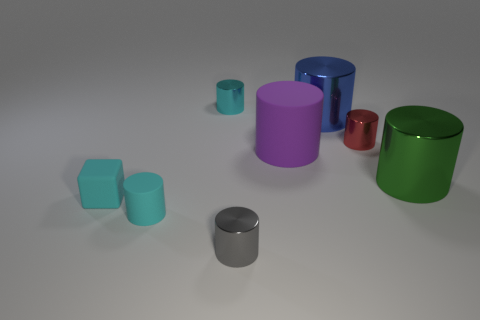There is another small cylinder that is the same color as the small rubber cylinder; what is its material?
Your answer should be compact. Metal. Are there more small gray cylinders that are right of the small gray metallic thing than purple matte things?
Ensure brevity in your answer.  No. What number of big matte cylinders are the same color as the tiny rubber block?
Your answer should be very brief. 0. What number of other objects are the same color as the small rubber block?
Offer a terse response. 2. Are there more gray cylinders than large gray rubber cylinders?
Your response must be concise. Yes. What is the blue cylinder made of?
Your answer should be very brief. Metal. There is a cyan cylinder that is in front of the purple matte thing; is its size the same as the green object?
Provide a short and direct response. No. What is the size of the rubber thing that is to the right of the gray shiny cylinder?
Your answer should be compact. Large. What number of red shiny cylinders are there?
Ensure brevity in your answer.  1. Is the tiny block the same color as the big matte thing?
Make the answer very short. No. 